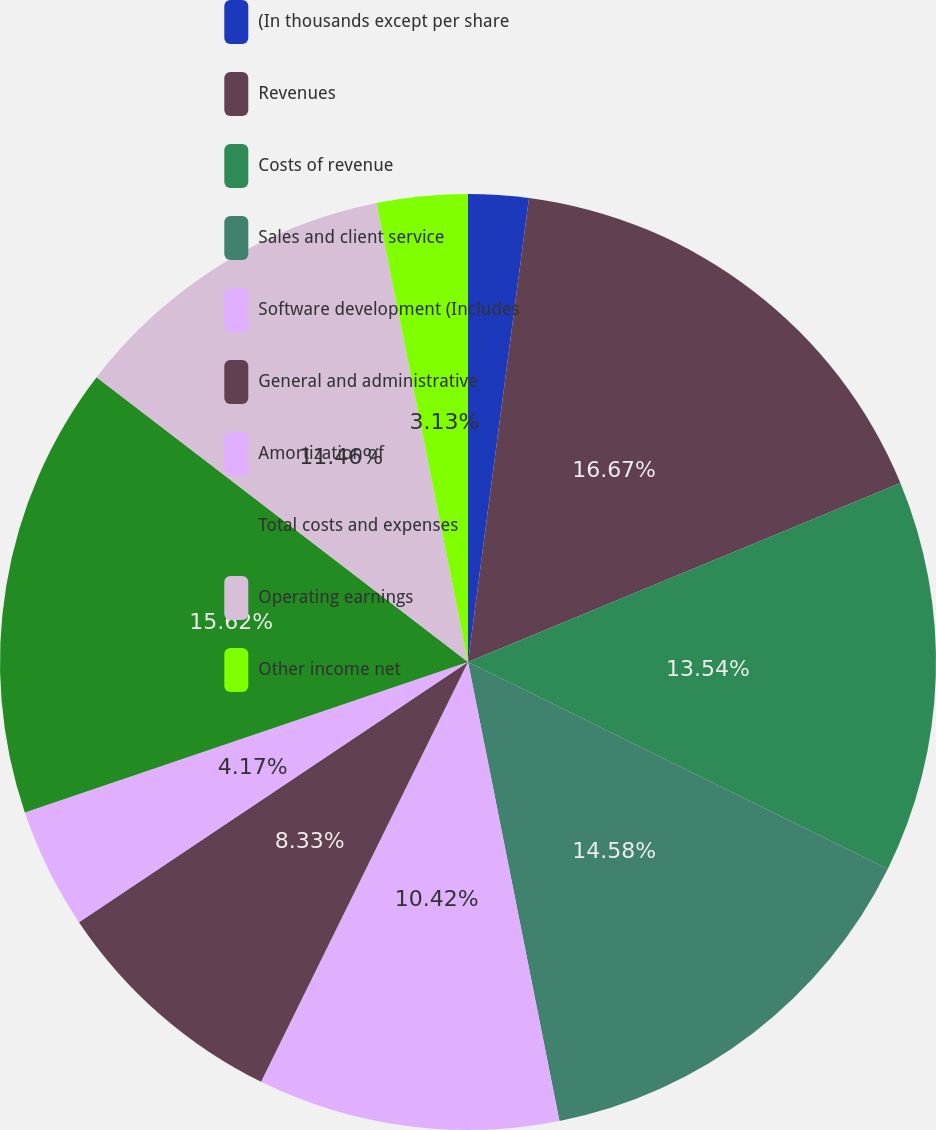Convert chart. <chart><loc_0><loc_0><loc_500><loc_500><pie_chart><fcel>(In thousands except per share<fcel>Revenues<fcel>Costs of revenue<fcel>Sales and client service<fcel>Software development (Includes<fcel>General and administrative<fcel>Amortization of<fcel>Total costs and expenses<fcel>Operating earnings<fcel>Other income net<nl><fcel>2.08%<fcel>16.67%<fcel>13.54%<fcel>14.58%<fcel>10.42%<fcel>8.33%<fcel>4.17%<fcel>15.62%<fcel>11.46%<fcel>3.13%<nl></chart> 